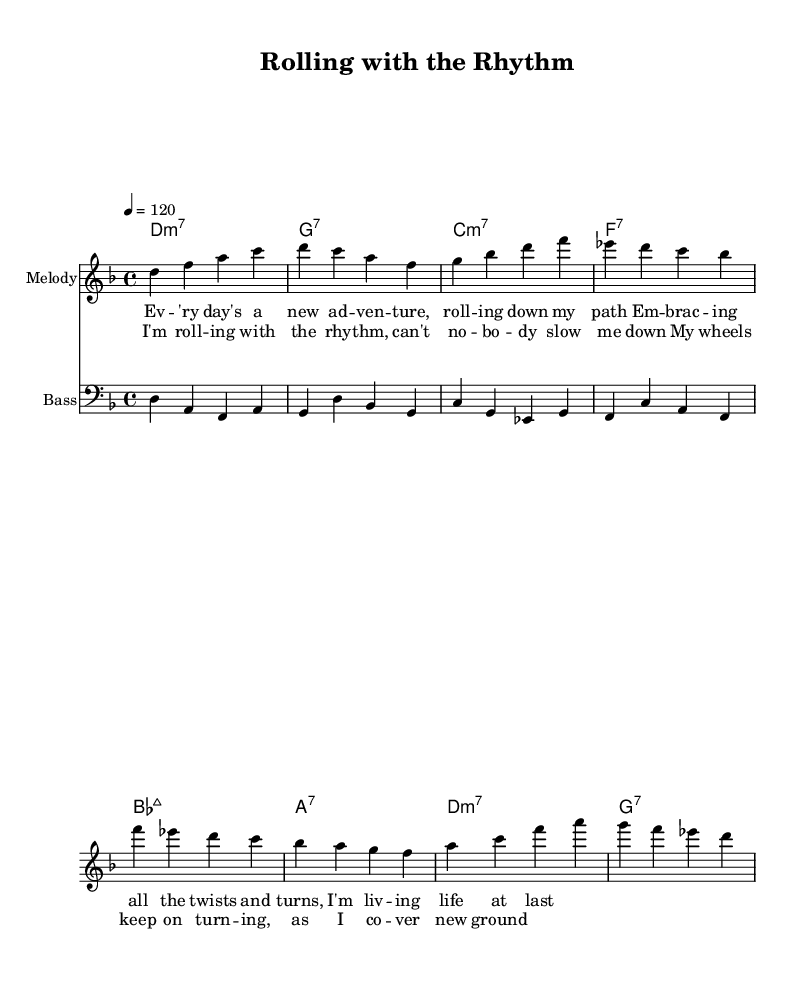What is the key signature of this music? The key signature is D minor, which has one flat (B flat).
Answer: D minor What is the time signature of the piece? The time signature is 4/4, which means there are four beats in each measure.
Answer: 4/4 What is the tempo marking for this piece? The tempo marking indicates a speed of 120 beats per minute, meaning the quarter note value is treated as one beat at this speed.
Answer: 120 How many measures are in the melody section? By counting the measures in the melody line, there are exactly eight measures present in the provided melody section.
Answer: Eight What is the first word of the lyrics? The lyrics begin with the word "Every," found in the first measure of the verse lyrics.
Answer: Every How does the bass line relate to the chords? The bass line notes correspond with the root notes of the chords above; for instance, the first bass note D aligns with the D7 chord, creating harmonic support.
Answer: Harmonic support What is the theme of the lyrics? The lyrics focus on themes of adventure and individuality, expressing a sense of empowerment through the message of overcoming challenges while rolling with the rhythm.
Answer: Empowerment 